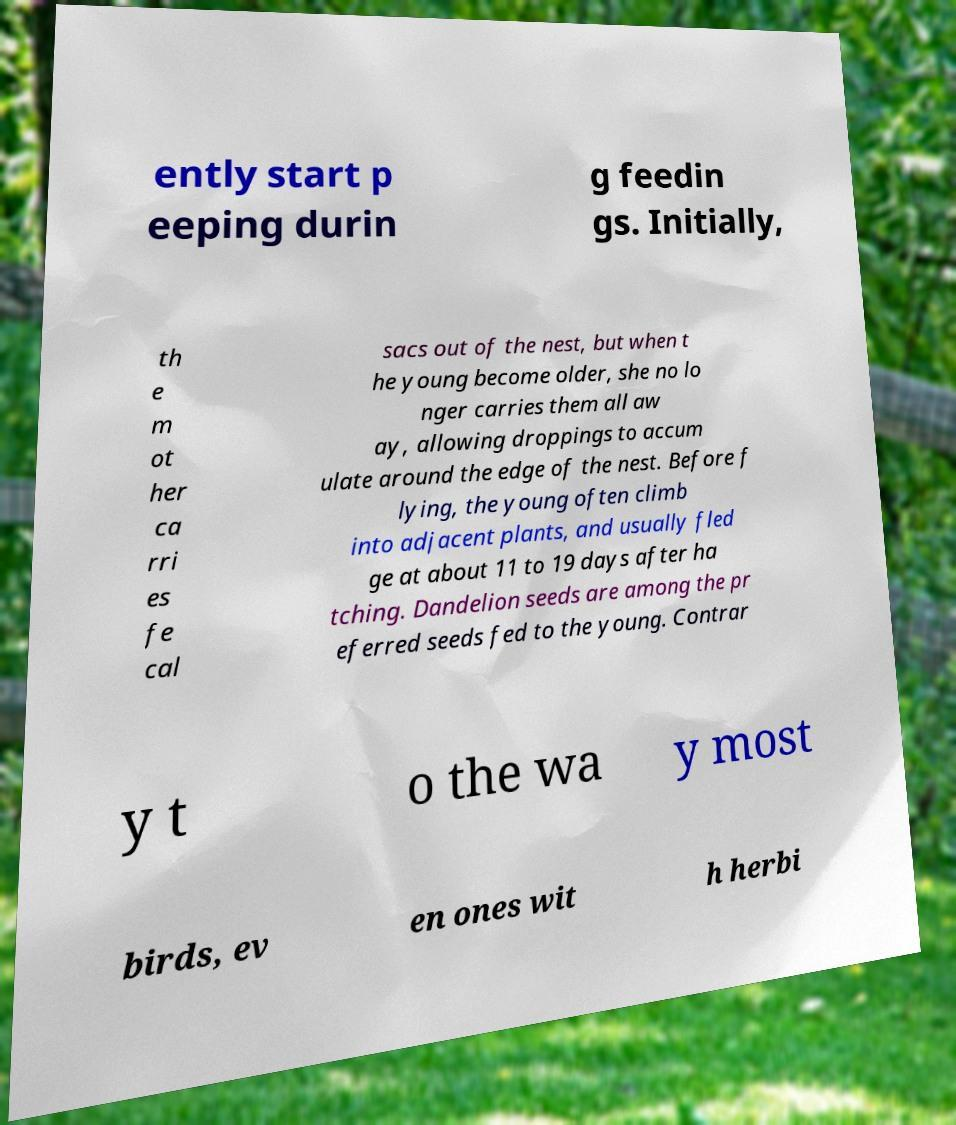Please identify and transcribe the text found in this image. ently start p eeping durin g feedin gs. Initially, th e m ot her ca rri es fe cal sacs out of the nest, but when t he young become older, she no lo nger carries them all aw ay, allowing droppings to accum ulate around the edge of the nest. Before f lying, the young often climb into adjacent plants, and usually fled ge at about 11 to 19 days after ha tching. Dandelion seeds are among the pr eferred seeds fed to the young. Contrar y t o the wa y most birds, ev en ones wit h herbi 